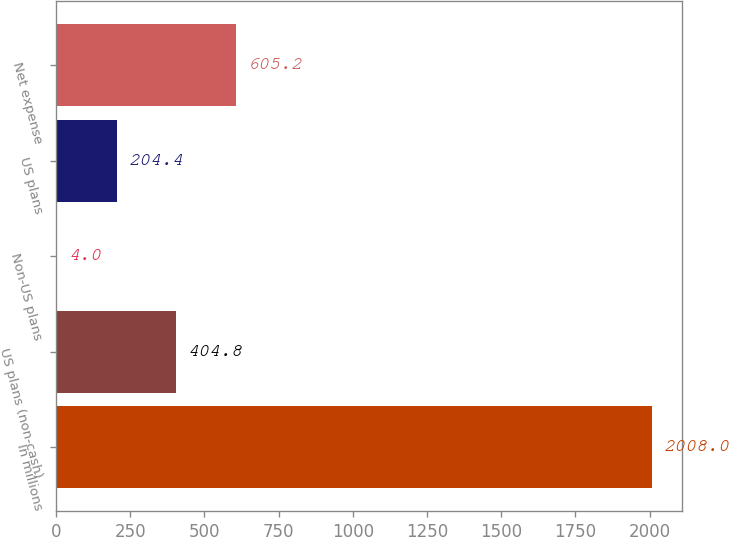Convert chart to OTSL. <chart><loc_0><loc_0><loc_500><loc_500><bar_chart><fcel>In millions<fcel>US plans (non-cash)<fcel>Non-US plans<fcel>US plans<fcel>Net expense<nl><fcel>2008<fcel>404.8<fcel>4<fcel>204.4<fcel>605.2<nl></chart> 